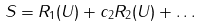Convert formula to latex. <formula><loc_0><loc_0><loc_500><loc_500>S = R _ { 1 } ( U ) + c _ { 2 } R _ { 2 } ( U ) + \dots</formula> 